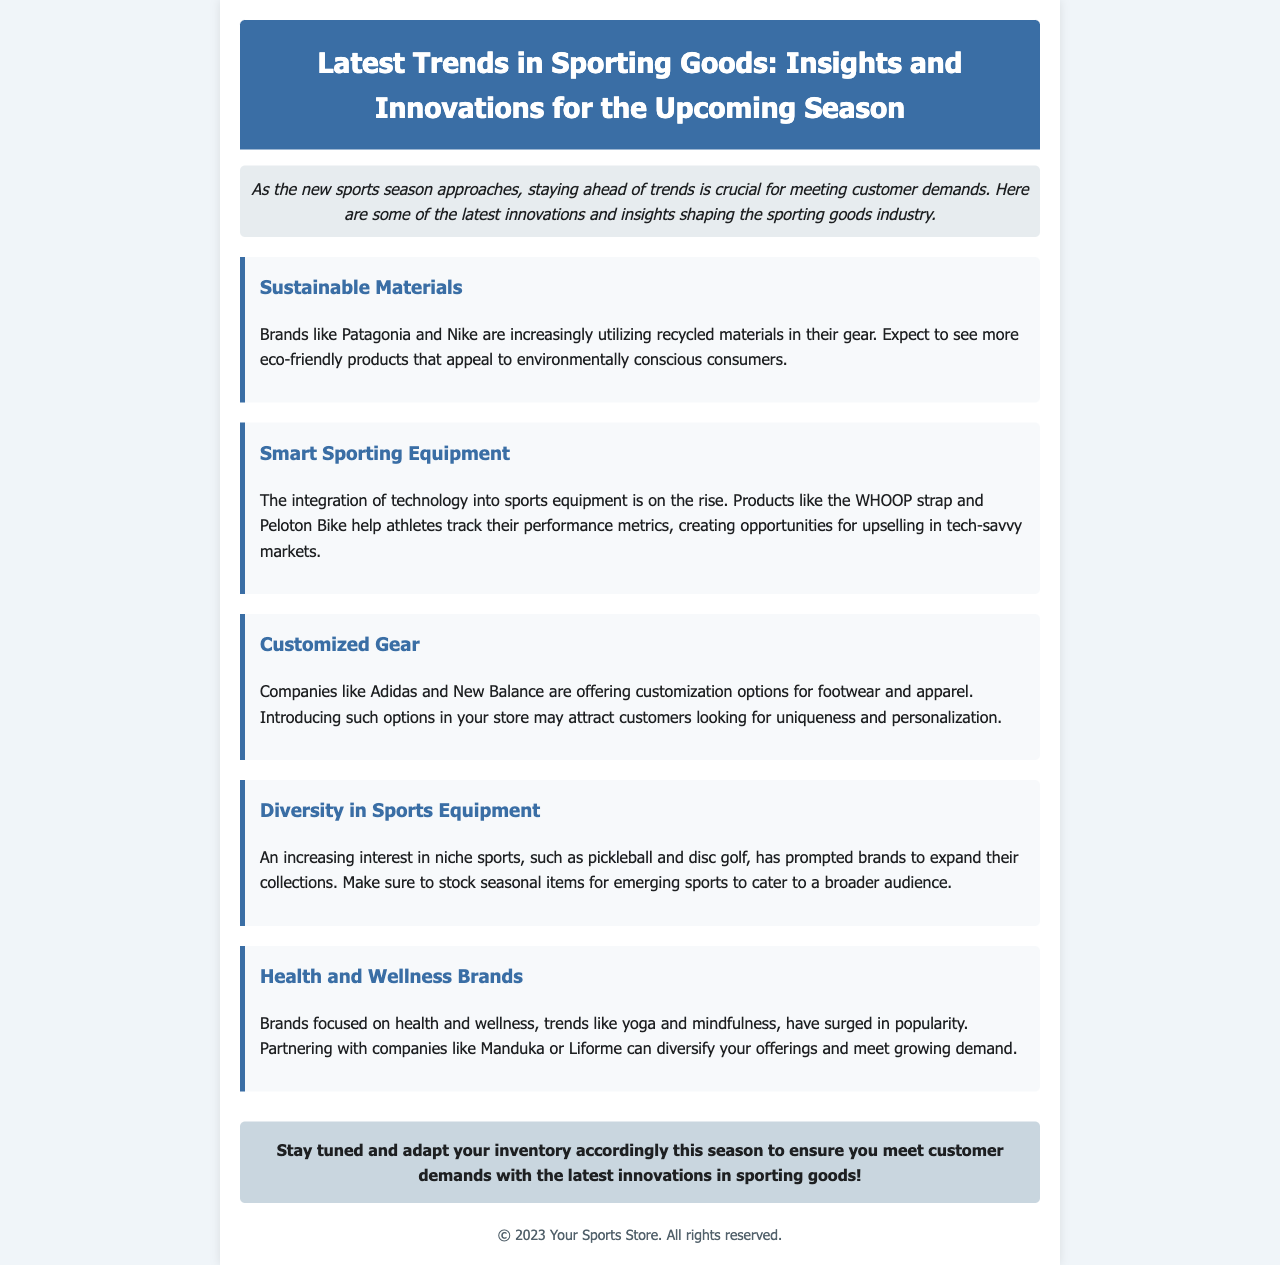What brand is known for utilizing recycled materials in their gear? The document mentions brands like Patagonia and Nike are increasingly utilizing recycled materials.
Answer: Patagonia and Nike What type of equipment is mentioned that helps track athletes' performance metrics? The document refers to products like the WHOOP strap and Peloton Bike that aid in tracking performance metrics.
Answer: WHOOP strap and Peloton Bike Which companies are noted for offering customization options for footwear and apparel? The companies highlighted in the document for customization options are Adidas and New Balance.
Answer: Adidas and New Balance What is driving the diversification in sports equipment offerings? The document indicates that an increasing interest in niche sports, such as pickleball and disc golf, is prompting brands to expand their collections.
Answer: Interest in niche sports Which health-focused brands are suggested for diversifying offerings? The document suggests partnering with companies like Manduka or Liforme to diversify offerings.
Answer: Manduka and Liforme What trend is crucial for meeting customer demands this season? The document emphasizes adapting inventory to meet the latest innovations in sporting goods as a crucial trend.
Answer: Latest innovations in sporting goods 